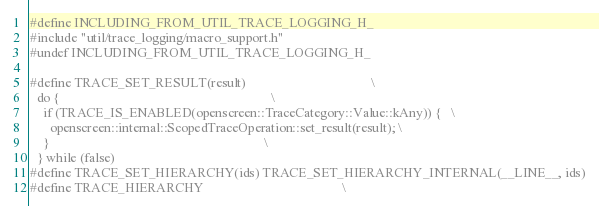Convert code to text. <code><loc_0><loc_0><loc_500><loc_500><_C_>
#define INCLUDING_FROM_UTIL_TRACE_LOGGING_H_
#include "util/trace_logging/macro_support.h"
#undef INCLUDING_FROM_UTIL_TRACE_LOGGING_H_

#define TRACE_SET_RESULT(result)                                      \
  do {                                                                \
    if (TRACE_IS_ENABLED(openscreen::TraceCategory::Value::kAny)) {   \
      openscreen::internal::ScopedTraceOperation::set_result(result); \
    }                                                                 \
  } while (false)
#define TRACE_SET_HIERARCHY(ids) TRACE_SET_HIERARCHY_INTERNAL(__LINE__, ids)
#define TRACE_HIERARCHY                                          \</code> 